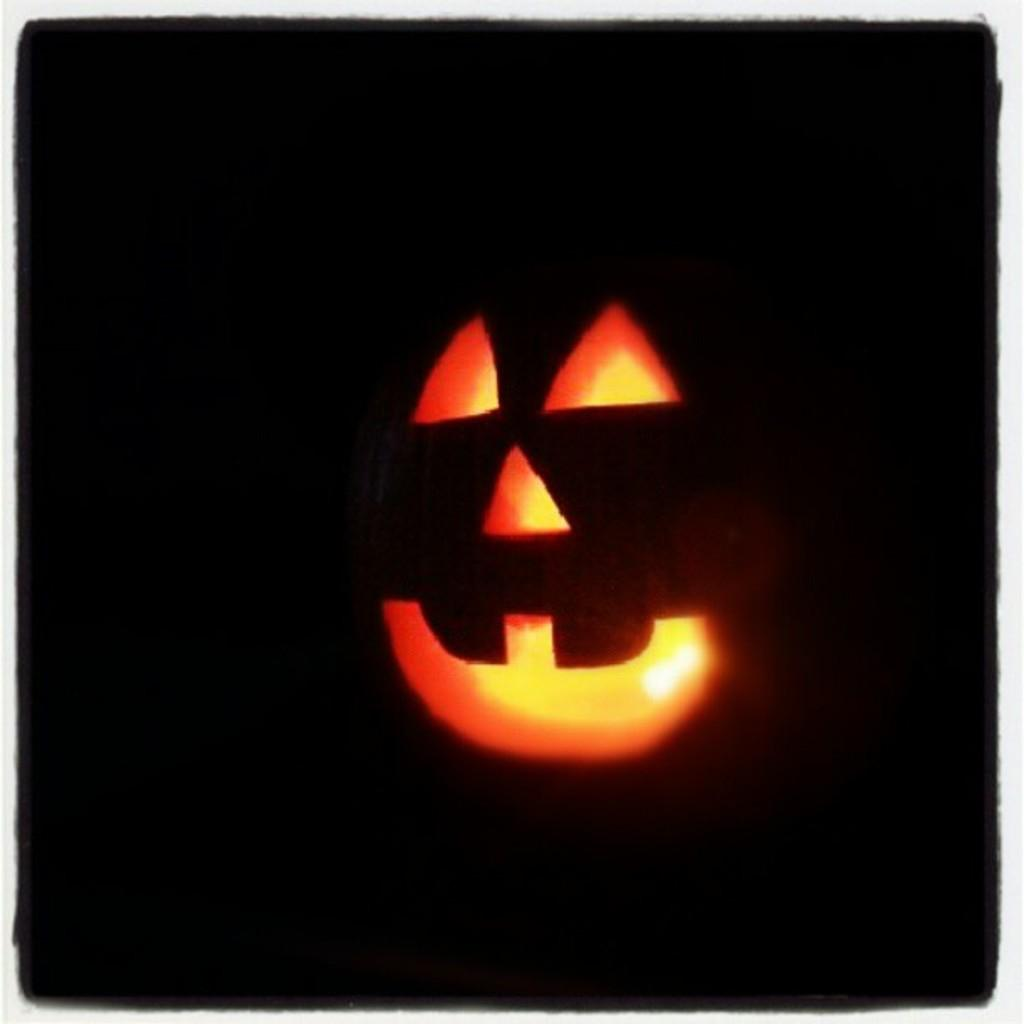What is the main object in the image? There is a pumpkin in the image. What is unique about the pumpkin? The pumpkin has a light inside it. How would you describe the overall appearance of the image? The background of the image is dark. Can you see the woman taking a bite out of the pumpkin in the image? There is no woman present in the image, and the pumpkin has a light inside it, not a bite taken out of it. 